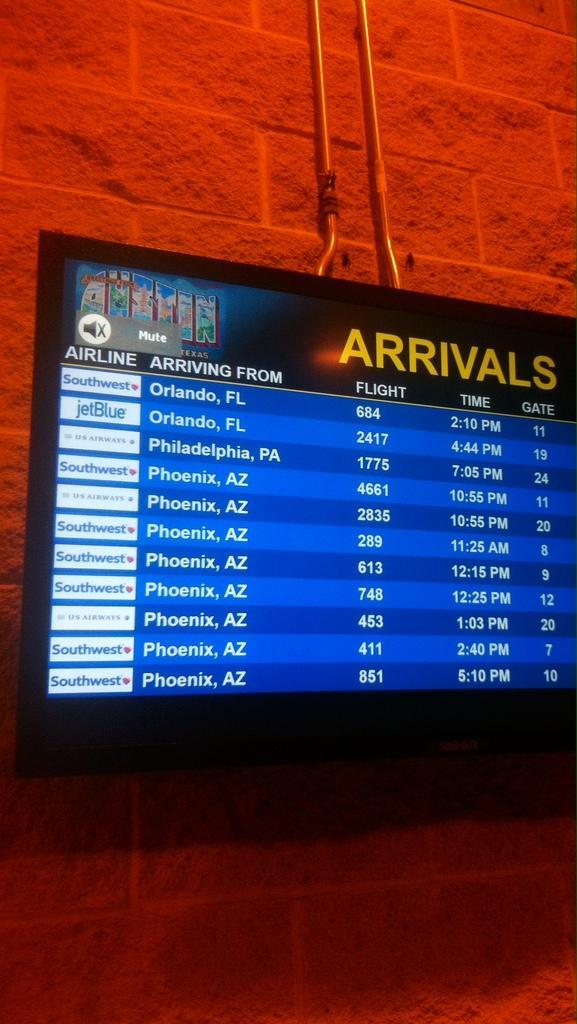Describe this image in one or two sentences. In this picture we can see a screen and other things on the wall. 